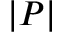<formula> <loc_0><loc_0><loc_500><loc_500>| P |</formula> 